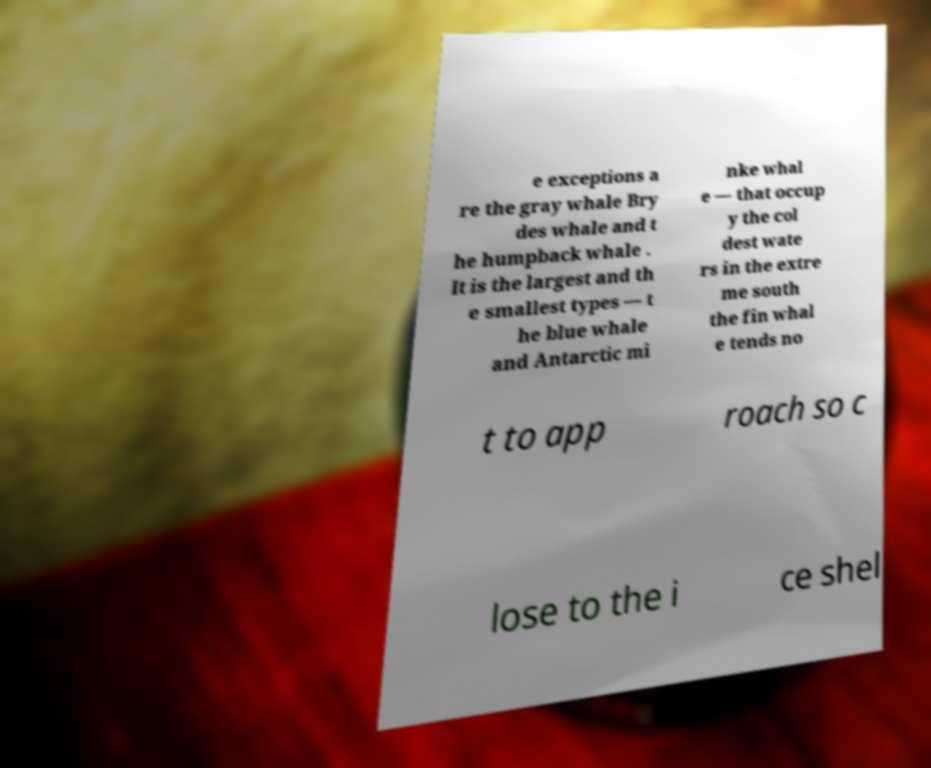I need the written content from this picture converted into text. Can you do that? e exceptions a re the gray whale Bry des whale and t he humpback whale . It is the largest and th e smallest types — t he blue whale and Antarctic mi nke whal e — that occup y the col dest wate rs in the extre me south the fin whal e tends no t to app roach so c lose to the i ce shel 